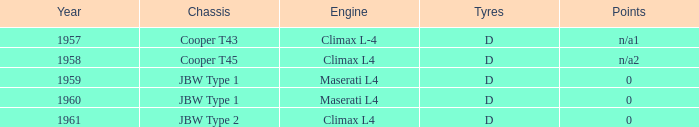What is the tyres for the JBW type 2 chassis? D. 